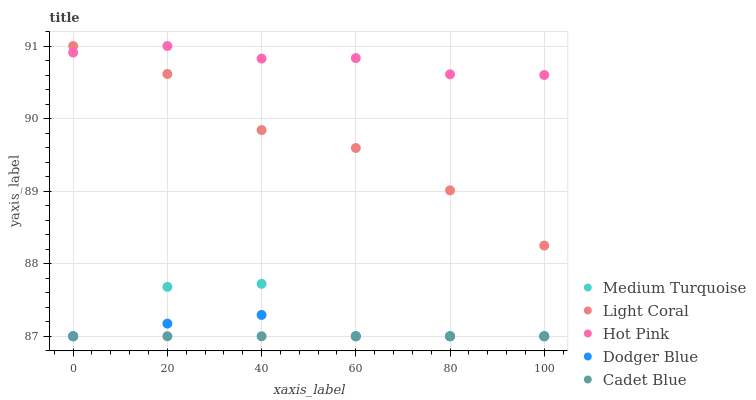Does Cadet Blue have the minimum area under the curve?
Answer yes or no. Yes. Does Hot Pink have the maximum area under the curve?
Answer yes or no. Yes. Does Hot Pink have the minimum area under the curve?
Answer yes or no. No. Does Cadet Blue have the maximum area under the curve?
Answer yes or no. No. Is Cadet Blue the smoothest?
Answer yes or no. Yes. Is Medium Turquoise the roughest?
Answer yes or no. Yes. Is Hot Pink the smoothest?
Answer yes or no. No. Is Hot Pink the roughest?
Answer yes or no. No. Does Cadet Blue have the lowest value?
Answer yes or no. Yes. Does Hot Pink have the lowest value?
Answer yes or no. No. Does Hot Pink have the highest value?
Answer yes or no. Yes. Does Cadet Blue have the highest value?
Answer yes or no. No. Is Dodger Blue less than Hot Pink?
Answer yes or no. Yes. Is Light Coral greater than Dodger Blue?
Answer yes or no. Yes. Does Medium Turquoise intersect Dodger Blue?
Answer yes or no. Yes. Is Medium Turquoise less than Dodger Blue?
Answer yes or no. No. Is Medium Turquoise greater than Dodger Blue?
Answer yes or no. No. Does Dodger Blue intersect Hot Pink?
Answer yes or no. No. 